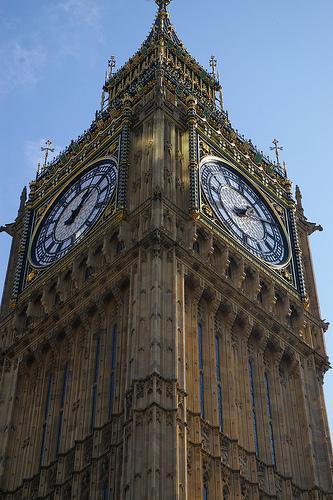How many clocks are shown?
Give a very brief answer. 2. 